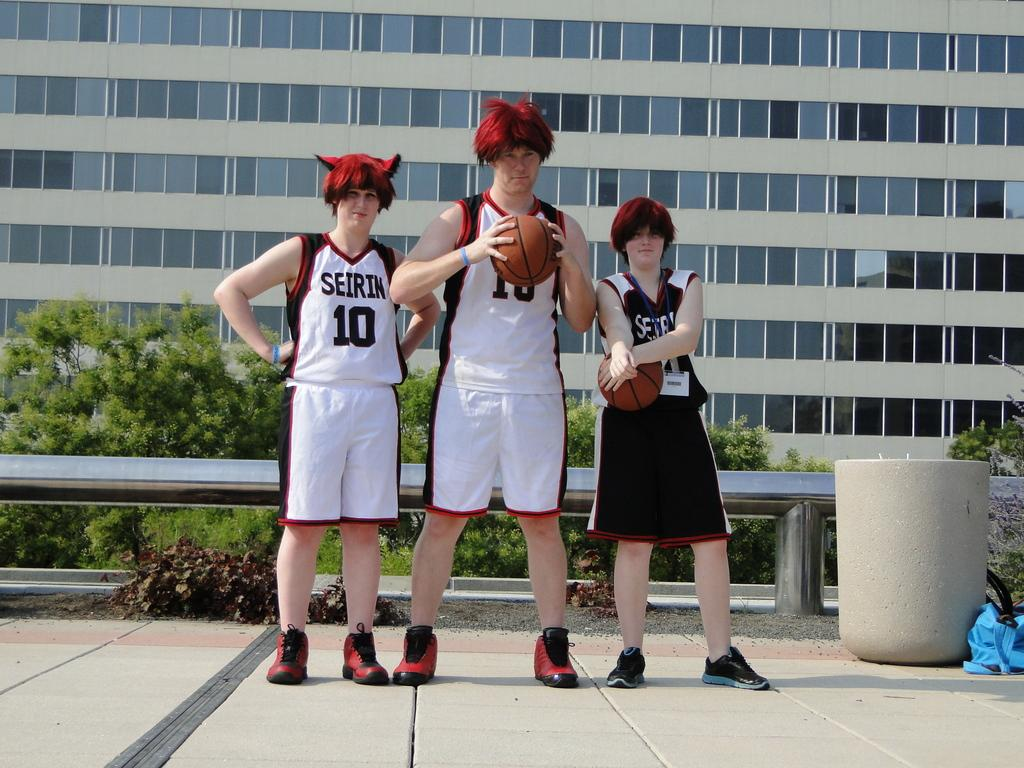How many people are in the image? There are three people in the image. What are the people doing in the image? The people are standing and holding a ball. What can be seen in the background of the image? There is a building, windows, trees, and fencing visible in the background. What type of insect is crawling on the farmer's hat in the image? There is no farmer or insect present in the image. Can you tell me how many copies of the ball are being held by the people in the image? The people are holding only one ball in the image, not multiple copies. 